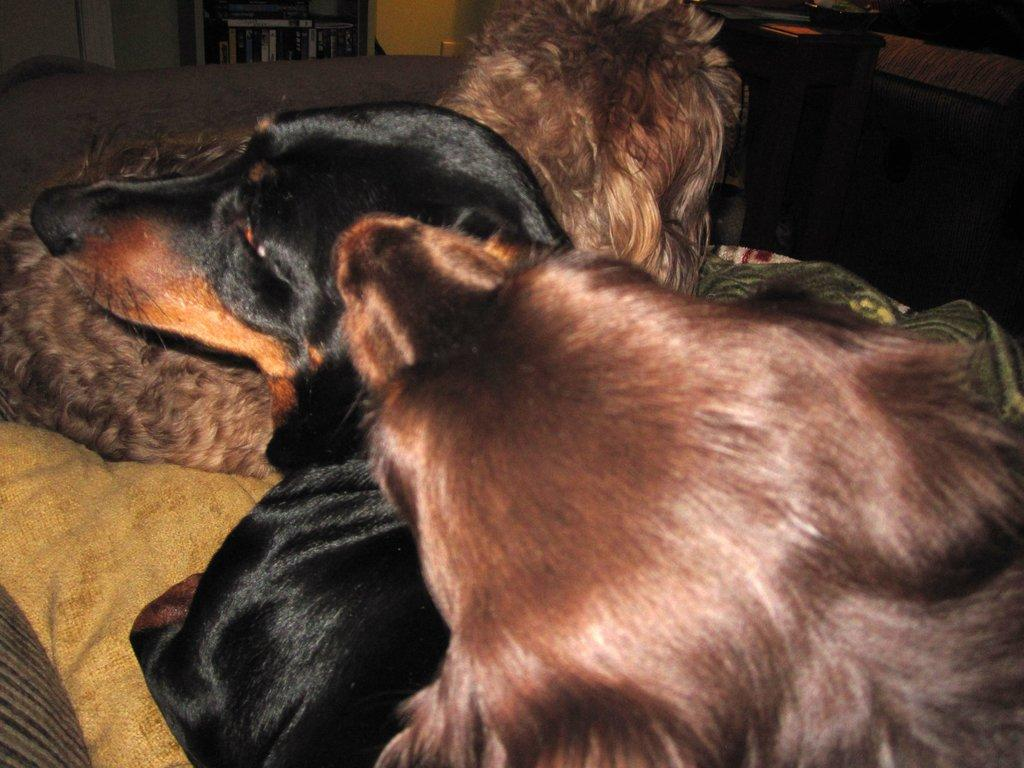What piece of furniture is at the bottom of the image? There is a couch at the bottom of the image. What is on the couch? There are dogs on the couch. What is behind the couch? There is a wall and a table behind the couch. What is on the table? There are books on the table. What army is marching through the room in the image? There is no army present in the image; it only features a couch, dogs, a wall, a table, and books. 